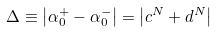Convert formula to latex. <formula><loc_0><loc_0><loc_500><loc_500>\Delta \equiv \left | \alpha _ { 0 } ^ { + } - \alpha _ { 0 } ^ { - } \right | = \left | c ^ { N } + d ^ { N } \right |</formula> 